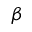Convert formula to latex. <formula><loc_0><loc_0><loc_500><loc_500>\beta</formula> 